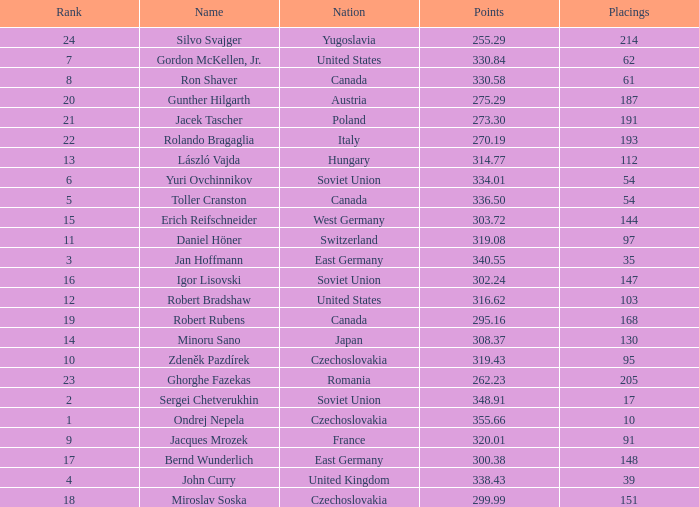Which Placings have a Nation of west germany, and Points larger than 303.72? None. 